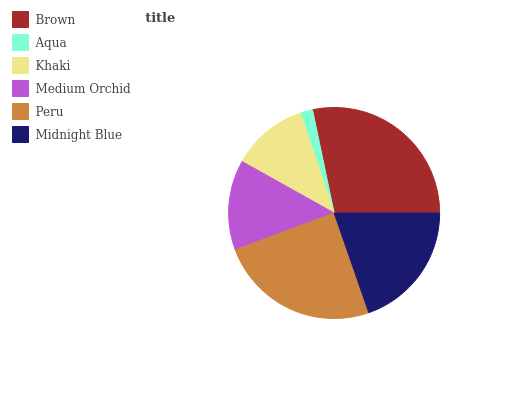Is Aqua the minimum?
Answer yes or no. Yes. Is Brown the maximum?
Answer yes or no. Yes. Is Khaki the minimum?
Answer yes or no. No. Is Khaki the maximum?
Answer yes or no. No. Is Khaki greater than Aqua?
Answer yes or no. Yes. Is Aqua less than Khaki?
Answer yes or no. Yes. Is Aqua greater than Khaki?
Answer yes or no. No. Is Khaki less than Aqua?
Answer yes or no. No. Is Midnight Blue the high median?
Answer yes or no. Yes. Is Medium Orchid the low median?
Answer yes or no. Yes. Is Aqua the high median?
Answer yes or no. No. Is Aqua the low median?
Answer yes or no. No. 